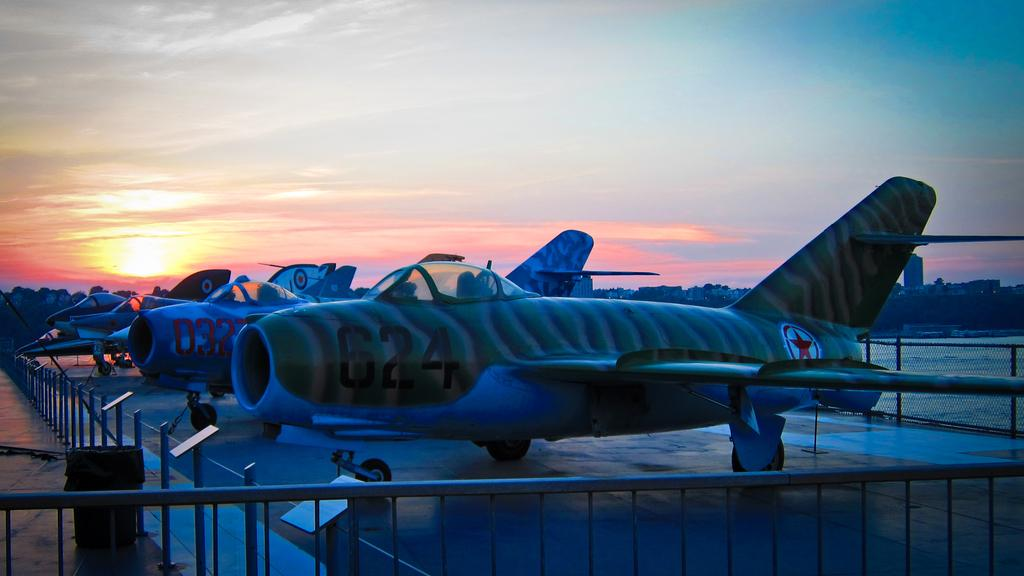Provide a one-sentence caption for the provided image. A fighter jet with the number 624 on it is parked next to several other numbered aircraft. 